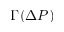Convert formula to latex. <formula><loc_0><loc_0><loc_500><loc_500>\Gamma ( \Delta P )</formula> 